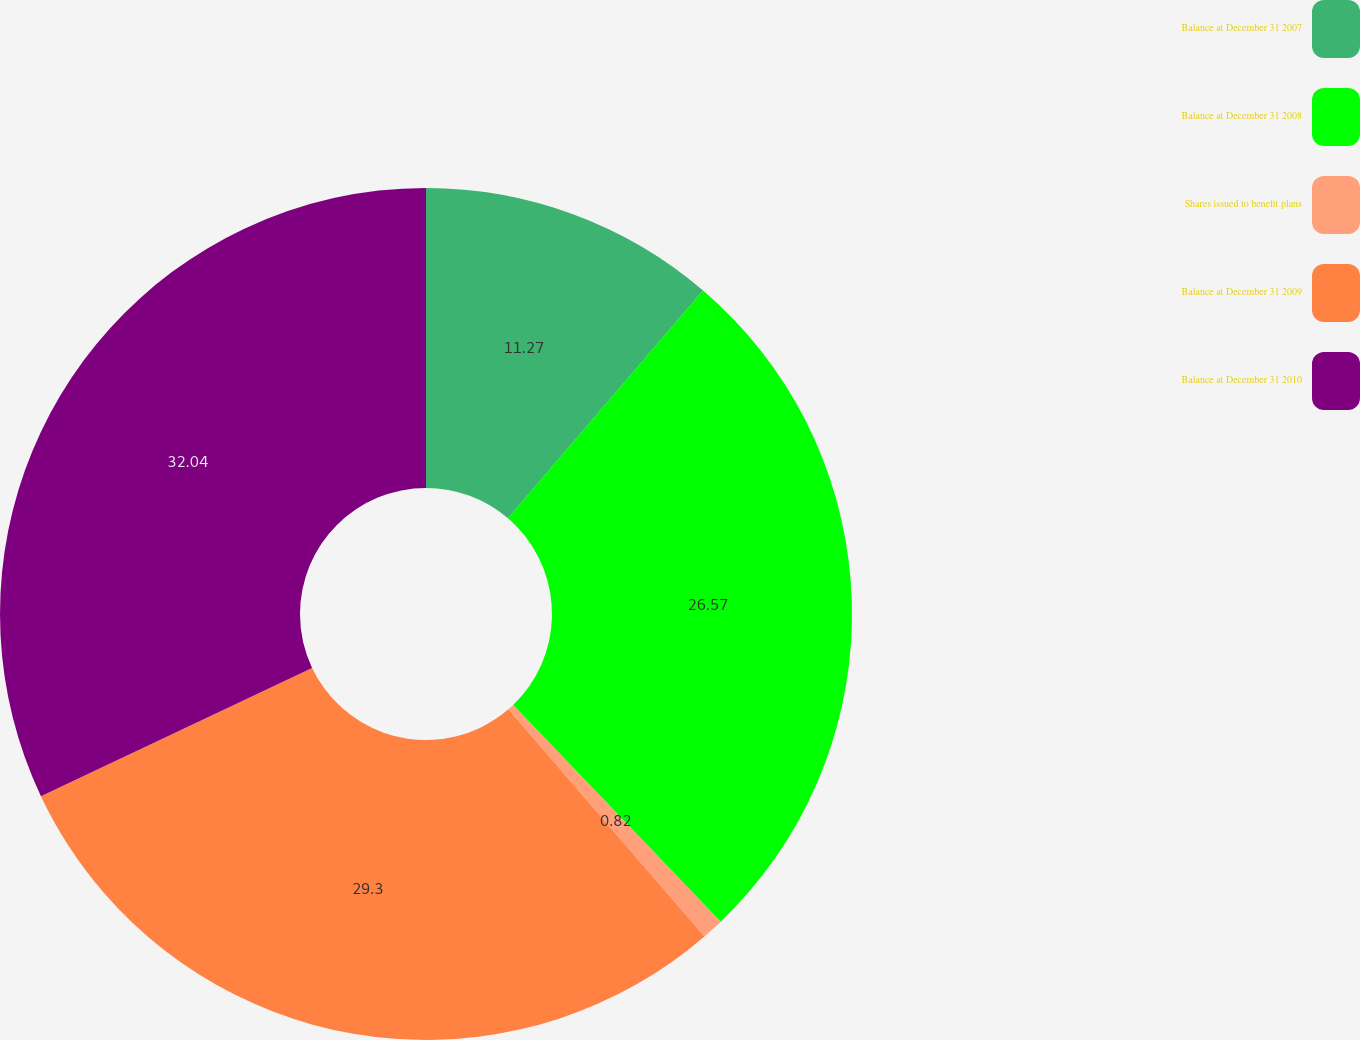Convert chart to OTSL. <chart><loc_0><loc_0><loc_500><loc_500><pie_chart><fcel>Balance at December 31 2007<fcel>Balance at December 31 2008<fcel>Shares issued to benefit plans<fcel>Balance at December 31 2009<fcel>Balance at December 31 2010<nl><fcel>11.27%<fcel>26.57%<fcel>0.82%<fcel>29.3%<fcel>32.03%<nl></chart> 